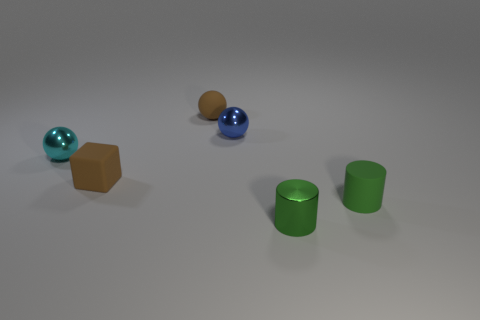Do the cyan thing and the small brown object that is in front of the tiny cyan thing have the same material?
Offer a terse response. No. How many other objects are the same shape as the green metal thing?
Make the answer very short. 1. Is the number of small cyan balls to the right of the blue shiny object less than the number of tiny things right of the brown block?
Provide a short and direct response. Yes. What number of small blue balls are there?
Provide a succinct answer. 1. What is the material of the brown thing that is the same shape as the small cyan metallic thing?
Keep it short and to the point. Rubber. Is the number of objects to the right of the tiny cyan ball less than the number of tiny things?
Your response must be concise. Yes. Does the small shiny thing on the right side of the tiny blue ball have the same shape as the small green matte object?
Your answer should be very brief. Yes. What is the size of the ball that is made of the same material as the cyan thing?
Offer a very short reply. Small. What is the material of the cyan thing behind the small cylinder that is in front of the small rubber thing that is on the right side of the tiny blue ball?
Keep it short and to the point. Metal. Are there fewer green rubber cylinders than cyan matte cubes?
Provide a succinct answer. No. 